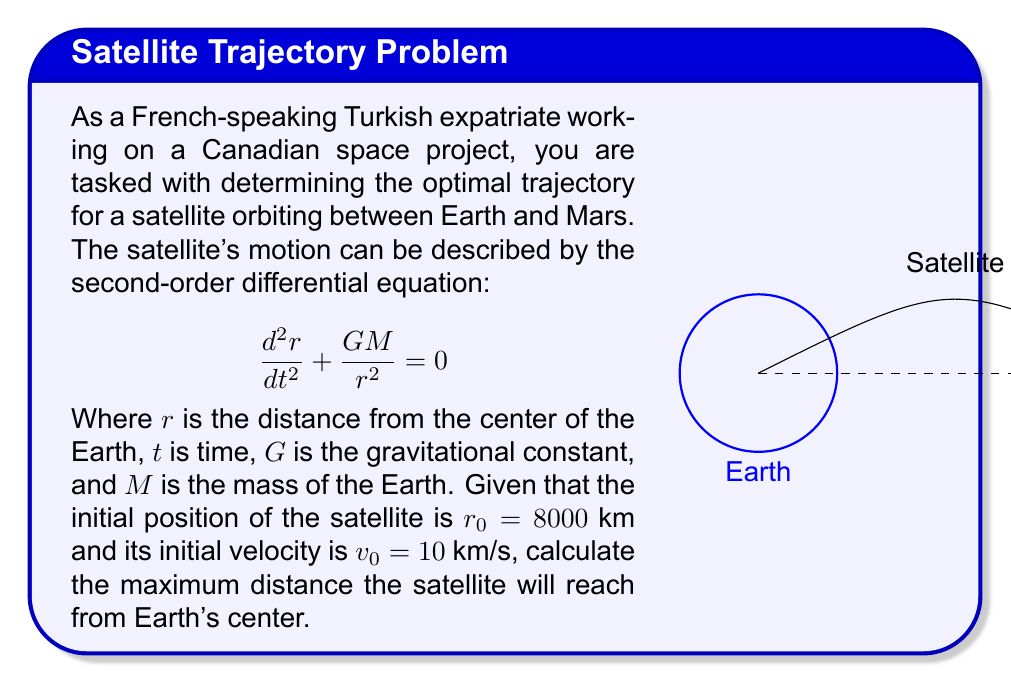Can you solve this math problem? To solve this problem, we'll follow these steps:

1) First, we need to recognize that this equation describes a central force problem, where the total energy (kinetic + potential) is conserved.

2) We can express the total energy $E$ as:

   $$E = \frac{1}{2}m\left(\frac{dr}{dt}\right)^2 - \frac{GMm}{r}$$

   Where $m$ is the mass of the satellite.

3) At the maximum distance, the radial velocity $\frac{dr}{dt}$ will be zero. Let's call this maximum distance $r_{max}$.

4) We can equate the initial energy to the energy at the maximum distance:

   $$\frac{1}{2}mv_0^2 - \frac{GMm}{r_0} = - \frac{GMm}{r_{max}}$$

5) The mass of the satellite $m$ cancels out on both sides:

   $$\frac{1}{2}v_0^2 - \frac{GM}{r_0} = - \frac{GM}{r_{max}}$$

6) Now, let's substitute the known values:
   $v_0 = 10$ km/s
   $r_0 = 8000$ km
   $GM = 3.986 \times 10^5$ km³/s² (Earth's standard gravitational parameter)

7) Plugging these into our equation:

   $$\frac{1}{2}(10)^2 - \frac{3.986 \times 10^5}{8000} = - \frac{3.986 \times 10^5}{r_{max}}$$

8) Simplifying:

   $$50 - 49.825 = - \frac{3.986 \times 10^5}{r_{max}}$$

9) Solving for $r_{max}$:

   $$r_{max} = \frac{3.986 \times 10^5}{0.175} \approx 2,277,714.29 \text{ km}$$

Therefore, the maximum distance the satellite will reach from Earth's center is approximately 2,277,714 km.
Answer: $r_{max} \approx 2,277,714 \text{ km}$ 